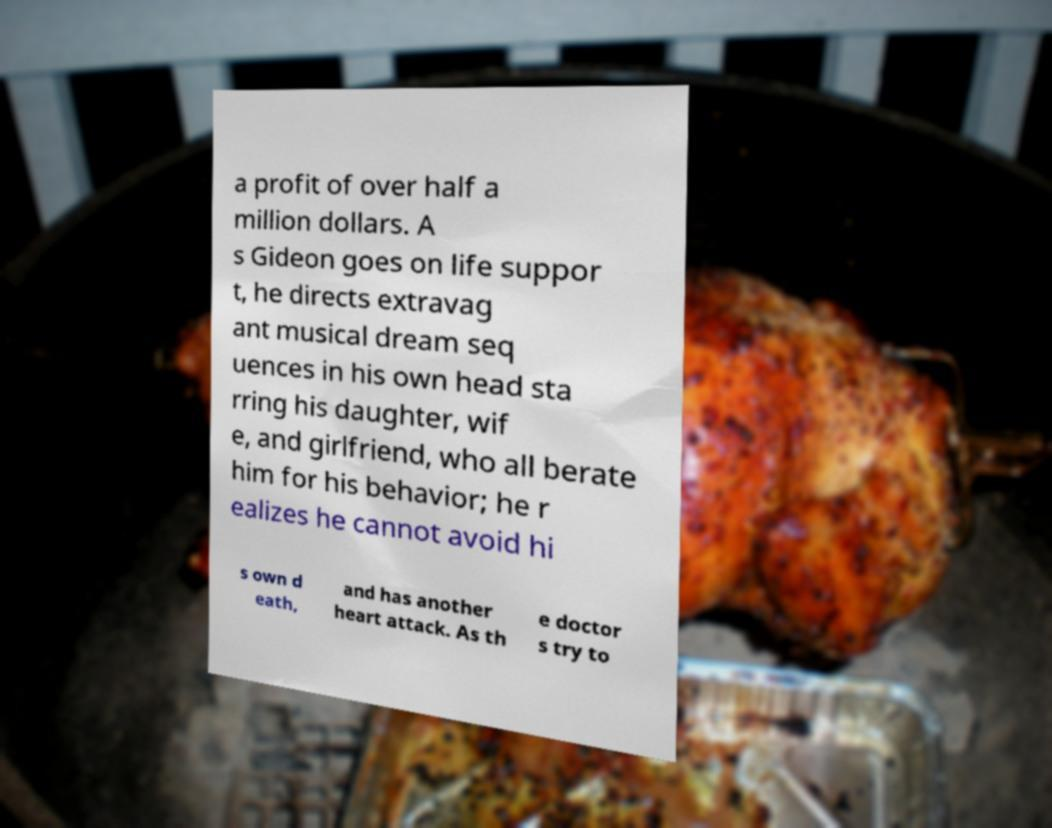For documentation purposes, I need the text within this image transcribed. Could you provide that? a profit of over half a million dollars. A s Gideon goes on life suppor t, he directs extravag ant musical dream seq uences in his own head sta rring his daughter, wif e, and girlfriend, who all berate him for his behavior; he r ealizes he cannot avoid hi s own d eath, and has another heart attack. As th e doctor s try to 